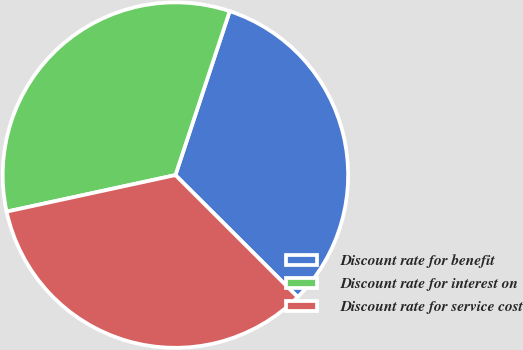Convert chart. <chart><loc_0><loc_0><loc_500><loc_500><pie_chart><fcel>Discount rate for benefit<fcel>Discount rate for interest on<fcel>Discount rate for service cost<nl><fcel>32.39%<fcel>33.49%<fcel>34.13%<nl></chart> 